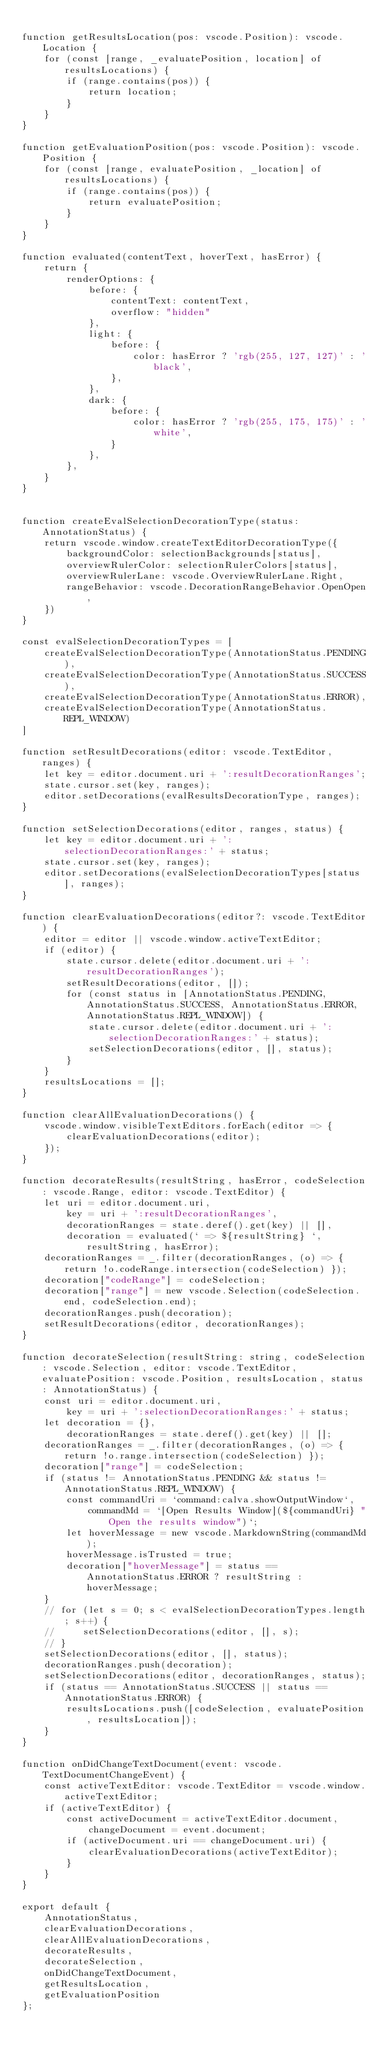Convert code to text. <code><loc_0><loc_0><loc_500><loc_500><_TypeScript_>
function getResultsLocation(pos: vscode.Position): vscode.Location {
    for (const [range, _evaluatePosition, location] of resultsLocations) {
        if (range.contains(pos)) {
            return location;
        }
    }
}

function getEvaluationPosition(pos: vscode.Position): vscode.Position {
    for (const [range, evaluatePosition, _location] of resultsLocations) {
        if (range.contains(pos)) {
            return evaluatePosition;
        }
    }
}

function evaluated(contentText, hoverText, hasError) {
    return {
        renderOptions: {
            before: {
                contentText: contentText,
                overflow: "hidden"
            },
            light: {
                before: {
                    color: hasError ? 'rgb(255, 127, 127)' : 'black',
                },
            },
            dark: {
                before: {
                    color: hasError ? 'rgb(255, 175, 175)' : 'white',
                }
            },
        },
    }
}


function createEvalSelectionDecorationType(status: AnnotationStatus) {
    return vscode.window.createTextEditorDecorationType({
        backgroundColor: selectionBackgrounds[status],
        overviewRulerColor: selectionRulerColors[status],
        overviewRulerLane: vscode.OverviewRulerLane.Right,
        rangeBehavior: vscode.DecorationRangeBehavior.OpenOpen,
    })
}

const evalSelectionDecorationTypes = [
    createEvalSelectionDecorationType(AnnotationStatus.PENDING),
    createEvalSelectionDecorationType(AnnotationStatus.SUCCESS),
    createEvalSelectionDecorationType(AnnotationStatus.ERROR),
    createEvalSelectionDecorationType(AnnotationStatus.REPL_WINDOW)
]

function setResultDecorations(editor: vscode.TextEditor, ranges) {
    let key = editor.document.uri + ':resultDecorationRanges';
    state.cursor.set(key, ranges);
    editor.setDecorations(evalResultsDecorationType, ranges);
}

function setSelectionDecorations(editor, ranges, status) {
    let key = editor.document.uri + ':selectionDecorationRanges:' + status;
    state.cursor.set(key, ranges);
    editor.setDecorations(evalSelectionDecorationTypes[status], ranges);
}

function clearEvaluationDecorations(editor?: vscode.TextEditor) {
    editor = editor || vscode.window.activeTextEditor;
    if (editor) {
        state.cursor.delete(editor.document.uri + ':resultDecorationRanges');
        setResultDecorations(editor, []);
        for (const status in [AnnotationStatus.PENDING, AnnotationStatus.SUCCESS, AnnotationStatus.ERROR, AnnotationStatus.REPL_WINDOW]) {
            state.cursor.delete(editor.document.uri + ':selectionDecorationRanges:' + status);
            setSelectionDecorations(editor, [], status);
        }
    }
    resultsLocations = [];
}

function clearAllEvaluationDecorations() {
    vscode.window.visibleTextEditors.forEach(editor => {
        clearEvaluationDecorations(editor);
    });
}

function decorateResults(resultString, hasError, codeSelection: vscode.Range, editor: vscode.TextEditor) {
    let uri = editor.document.uri,
        key = uri + ':resultDecorationRanges',
        decorationRanges = state.deref().get(key) || [],
        decoration = evaluated(` => ${resultString} `, resultString, hasError);
    decorationRanges = _.filter(decorationRanges, (o) => { return !o.codeRange.intersection(codeSelection) });
    decoration["codeRange"] = codeSelection;
    decoration["range"] = new vscode.Selection(codeSelection.end, codeSelection.end);
    decorationRanges.push(decoration);
    setResultDecorations(editor, decorationRanges);
}

function decorateSelection(resultString: string, codeSelection: vscode.Selection, editor: vscode.TextEditor, evaluatePosition: vscode.Position, resultsLocation, status: AnnotationStatus) {
    const uri = editor.document.uri,
        key = uri + ':selectionDecorationRanges:' + status;
    let decoration = {},
        decorationRanges = state.deref().get(key) || [];
    decorationRanges = _.filter(decorationRanges, (o) => { return !o.range.intersection(codeSelection) });
    decoration["range"] = codeSelection;
    if (status != AnnotationStatus.PENDING && status != AnnotationStatus.REPL_WINDOW) {
        const commandUri = `command:calva.showOutputWindow`,
            commandMd = `[Open Results Window](${commandUri} "Open the results window")`;
        let hoverMessage = new vscode.MarkdownString(commandMd);
        hoverMessage.isTrusted = true;
        decoration["hoverMessage"] = status == AnnotationStatus.ERROR ? resultString : hoverMessage;
    }
    // for (let s = 0; s < evalSelectionDecorationTypes.length; s++) {
    //     setSelectionDecorations(editor, [], s);
    // }
    setSelectionDecorations(editor, [], status);
    decorationRanges.push(decoration);
    setSelectionDecorations(editor, decorationRanges, status);
    if (status == AnnotationStatus.SUCCESS || status == AnnotationStatus.ERROR) {
        resultsLocations.push([codeSelection, evaluatePosition, resultsLocation]);
    }
}

function onDidChangeTextDocument(event: vscode.TextDocumentChangeEvent) {
    const activeTextEditor: vscode.TextEditor = vscode.window.activeTextEditor;
    if (activeTextEditor) {
        const activeDocument = activeTextEditor.document,
            changeDocument = event.document;
        if (activeDocument.uri == changeDocument.uri) {
            clearEvaluationDecorations(activeTextEditor);
        }
    }
}

export default {
    AnnotationStatus,
    clearEvaluationDecorations,
    clearAllEvaluationDecorations,
    decorateResults,
    decorateSelection,
    onDidChangeTextDocument,
    getResultsLocation,
    getEvaluationPosition
};</code> 